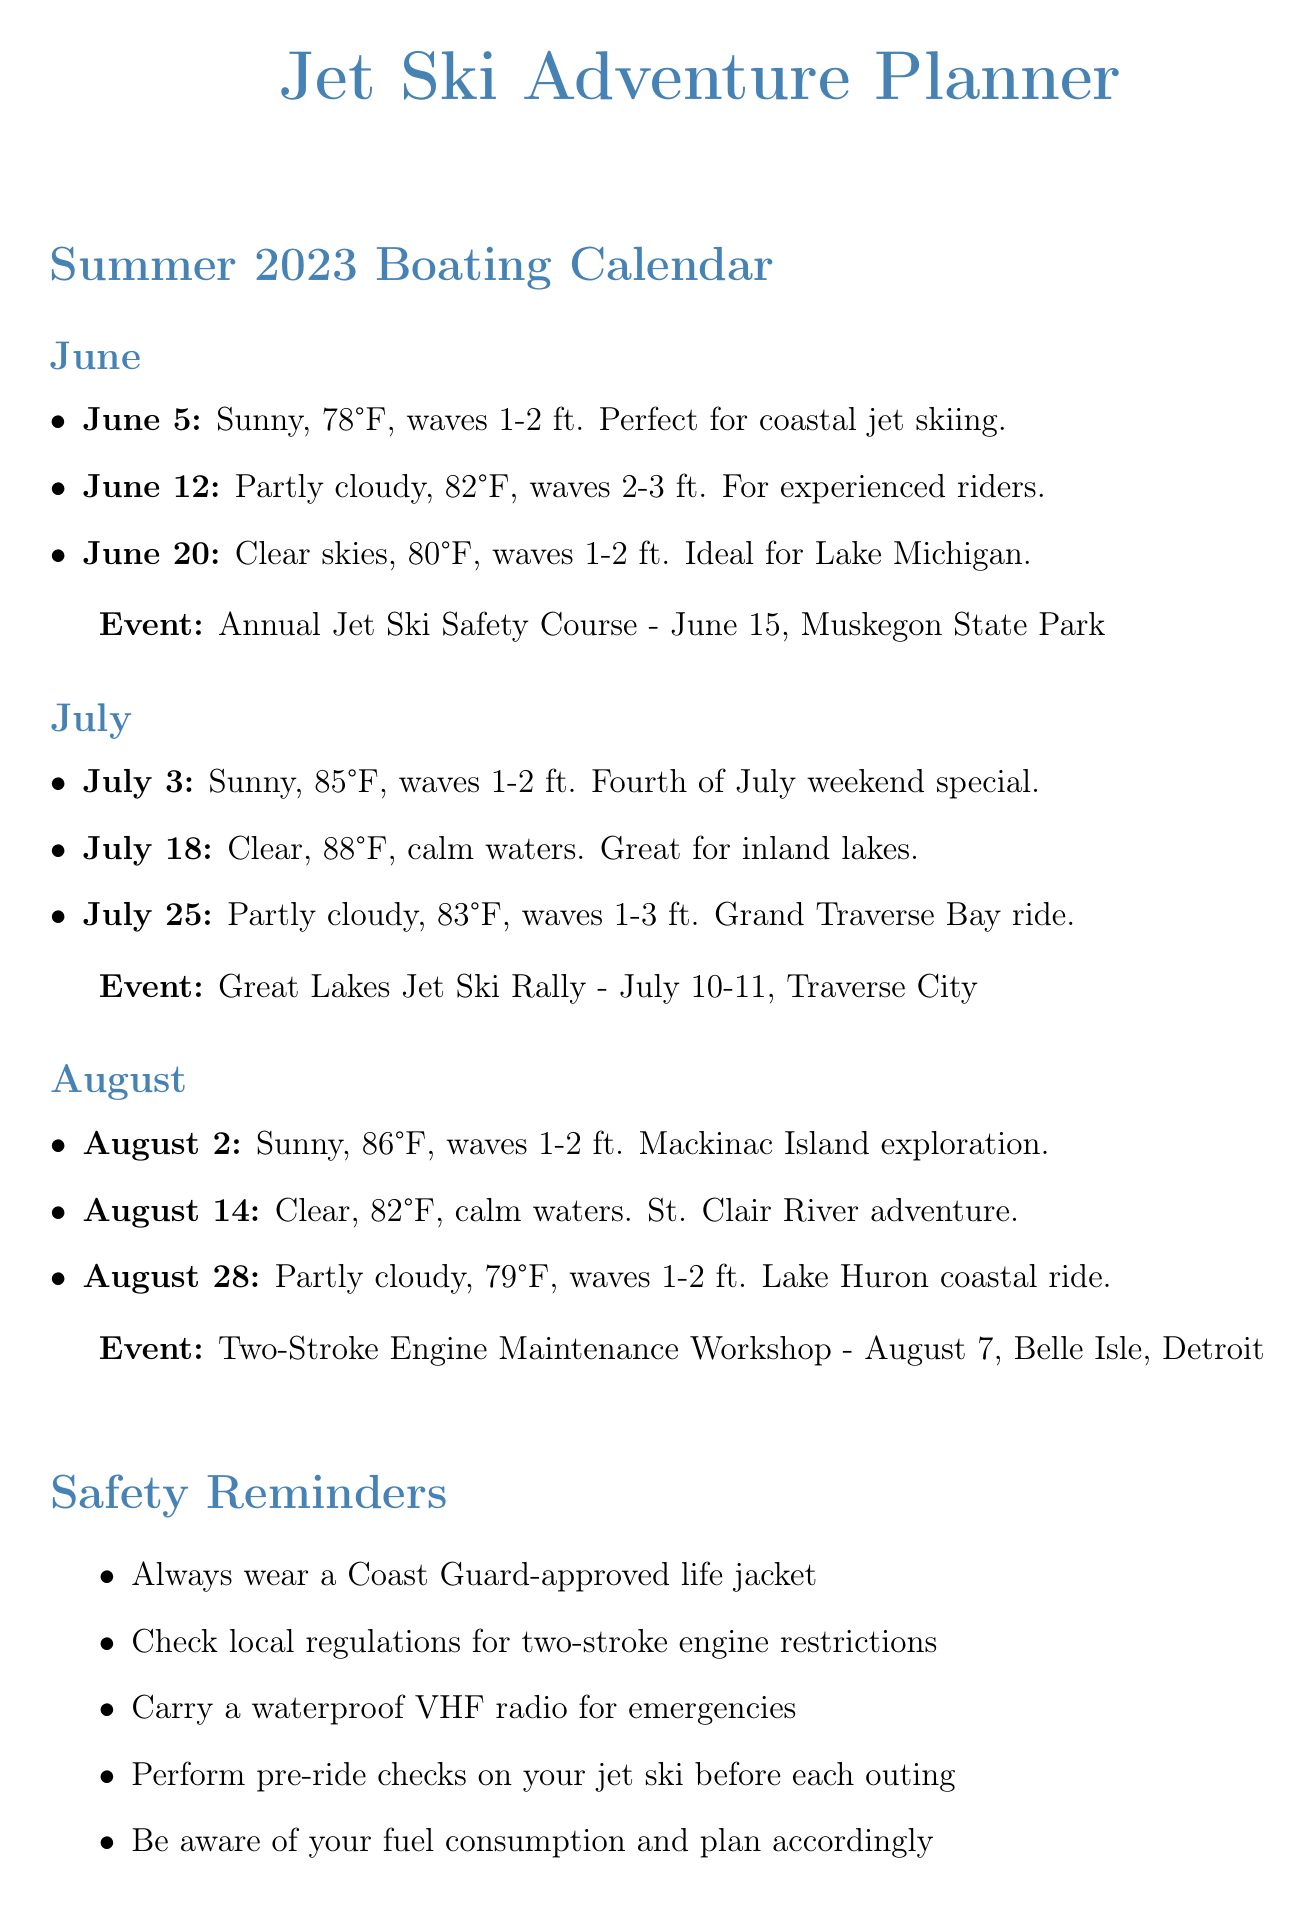What is the ideal day for jet skiing in June? The document lists ideal days for jet skiing in June, including June 5, June 12, and June 20.
Answer: June 5 What is the temperature on July 18? The document states the temperature for July 18 is 88°F.
Answer: 88°F When is the Great Lakes Jet Ski Rally? The event table provides the date for the Great Lakes Jet Ski Rally, which is July 10-11.
Answer: July 10-11 What is the wave height on August 14? The document specifies that the wave height on August 14 is 0-1 foot.
Answer: 0-1 foot How many ideal days are listed for August? The document lists three ideal days for August.
Answer: Three Which month has an event for two-stroke engine maintenance? The section detailing events shows that the Two-Stroke Engine Maintenance Workshop occurs in August.
Answer: August What should always be worn for safety? The safety reminders highlight the importance of wearing a Coast Guard-approved life jacket.
Answer: Life jacket Which location is known for its sand dunes? The popular jet ski locations section describes Silver Lake State Park as known for its sand dunes.
Answer: Silver Lake State Park What is an environmental consideration mentioned in the document? The environmental considerations outline multiple items, one example is using environmentally friendly two-stroke oil.
Answer: Environmentally friendly two-stroke oil 